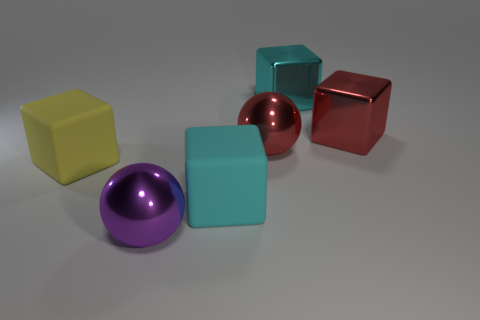There is a red object on the right side of the cyan metal cube; does it have the same size as the purple object?
Provide a short and direct response. Yes. How many other matte objects are the same shape as the yellow thing?
Your answer should be compact. 1. Are there the same number of big yellow blocks to the right of the big yellow block and tiny red shiny spheres?
Provide a succinct answer. Yes. There is a rubber object that is to the right of the yellow block; does it have the same shape as the large matte thing on the left side of the purple metallic thing?
Make the answer very short. Yes. There is another cyan thing that is the same shape as the cyan rubber object; what is its material?
Offer a terse response. Metal. There is a big metallic thing that is on the right side of the big red metallic sphere and in front of the cyan metallic block; what is its color?
Give a very brief answer. Red. There is a metal sphere that is in front of the cube on the left side of the big purple object; is there a yellow matte thing in front of it?
Ensure brevity in your answer.  No. What number of things are either large red metallic things or big yellow cubes?
Make the answer very short. 3. Is the material of the purple thing the same as the big cyan cube that is in front of the yellow matte object?
Your response must be concise. No. What number of things are big red metal objects that are on the left side of the large cyan metallic cube or matte blocks to the right of the purple metal object?
Keep it short and to the point. 2. 